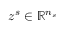Convert formula to latex. <formula><loc_0><loc_0><loc_500><loc_500>z ^ { s } \in \mathbb { R } ^ { n _ { s } }</formula> 